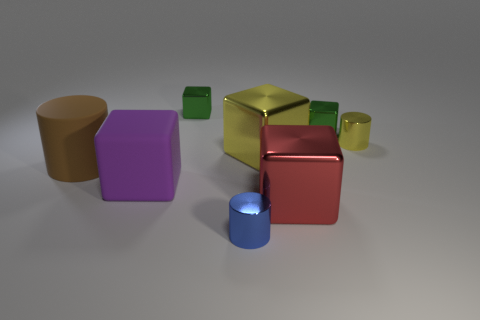There is a tiny yellow metallic cylinder on the right side of the large object in front of the purple block; is there a small block in front of it?
Your answer should be compact. No. Is the number of tiny metallic cubes greater than the number of cylinders?
Offer a very short reply. No. There is a small metallic cylinder that is left of the tiny yellow metal thing; what is its color?
Give a very brief answer. Blue. Are there more shiny cylinders that are behind the purple cube than red metallic spheres?
Provide a succinct answer. Yes. Do the large brown thing and the red cube have the same material?
Provide a short and direct response. No. What number of other objects are the same shape as the tiny blue thing?
Keep it short and to the point. 2. There is a small cylinder that is behind the cylinder that is in front of the large block in front of the purple matte cube; what is its color?
Your answer should be compact. Yellow. Does the small metal thing in front of the small yellow cylinder have the same shape as the brown matte object?
Your response must be concise. Yes. How many tiny blue matte cylinders are there?
Ensure brevity in your answer.  0. How many red cubes have the same size as the brown rubber object?
Keep it short and to the point. 1. 